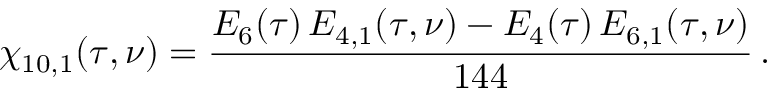Convert formula to latex. <formula><loc_0><loc_0><loc_500><loc_500>\chi _ { 1 0 , 1 } ( \tau , \nu ) = \frac { E _ { 6 } ( \tau ) \, E _ { 4 , 1 } ( \tau , \nu ) - E _ { 4 } ( \tau ) \, E _ { 6 , 1 } ( \tau , \nu ) } { 1 4 4 } \, .</formula> 